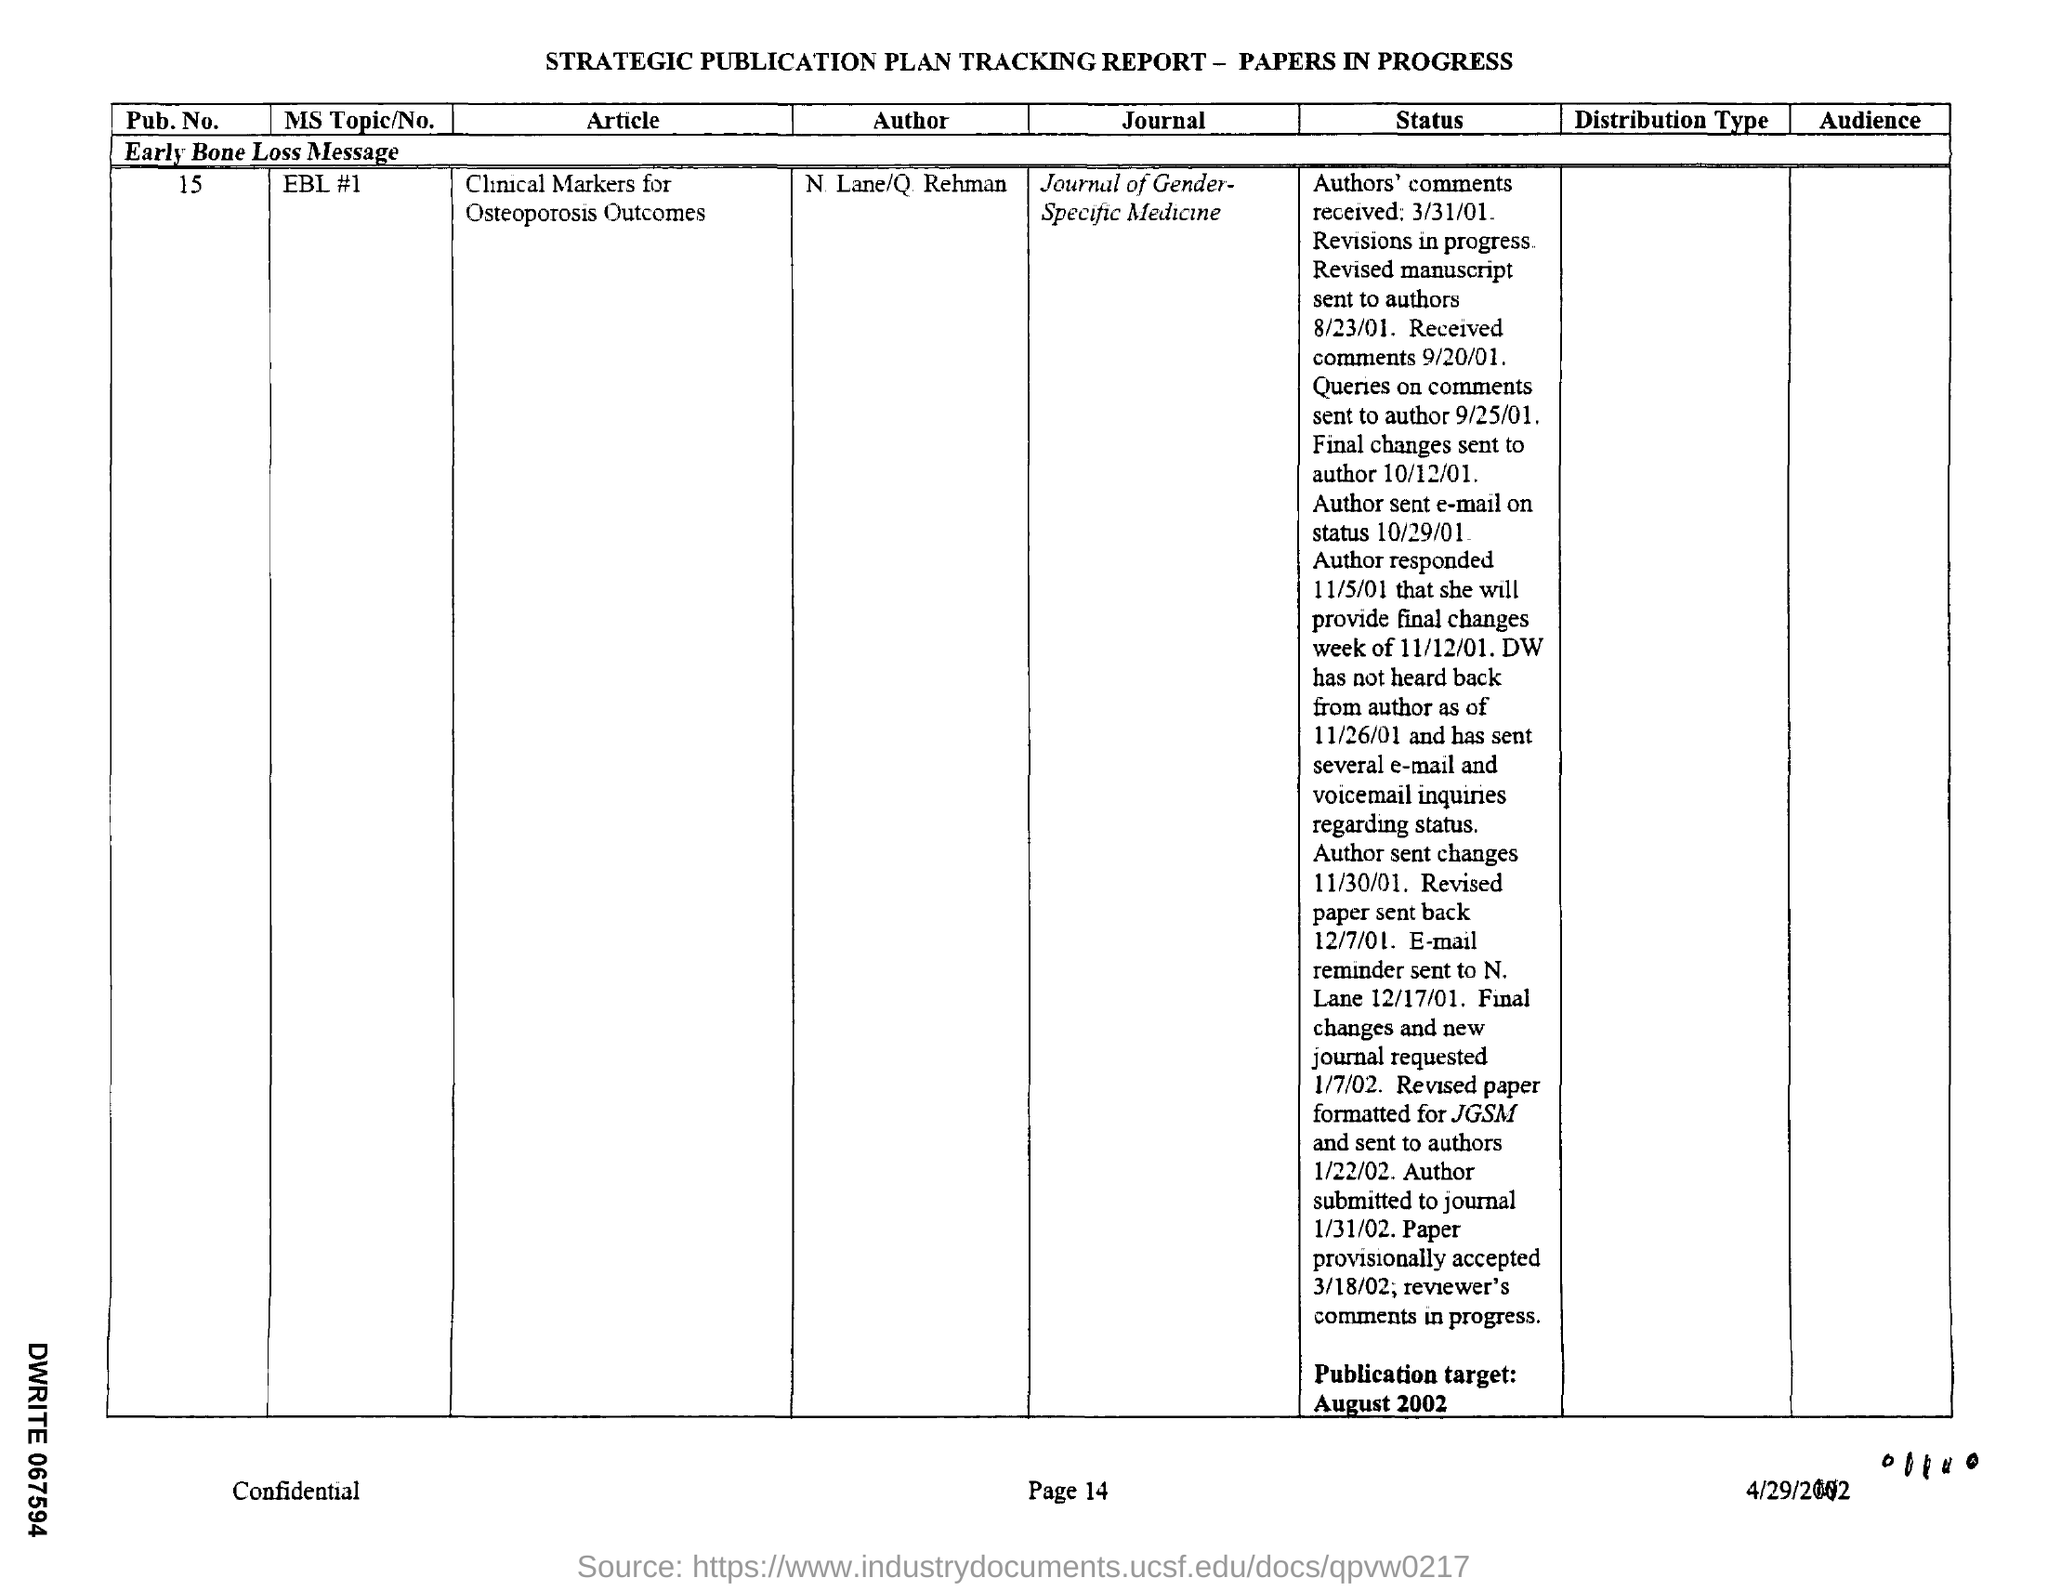What is the pub.no. mentioned in the report ?
Give a very brief answer. 15. What is ms topic/no mentioned in the given report ?
Your response must be concise. EBL #1. 